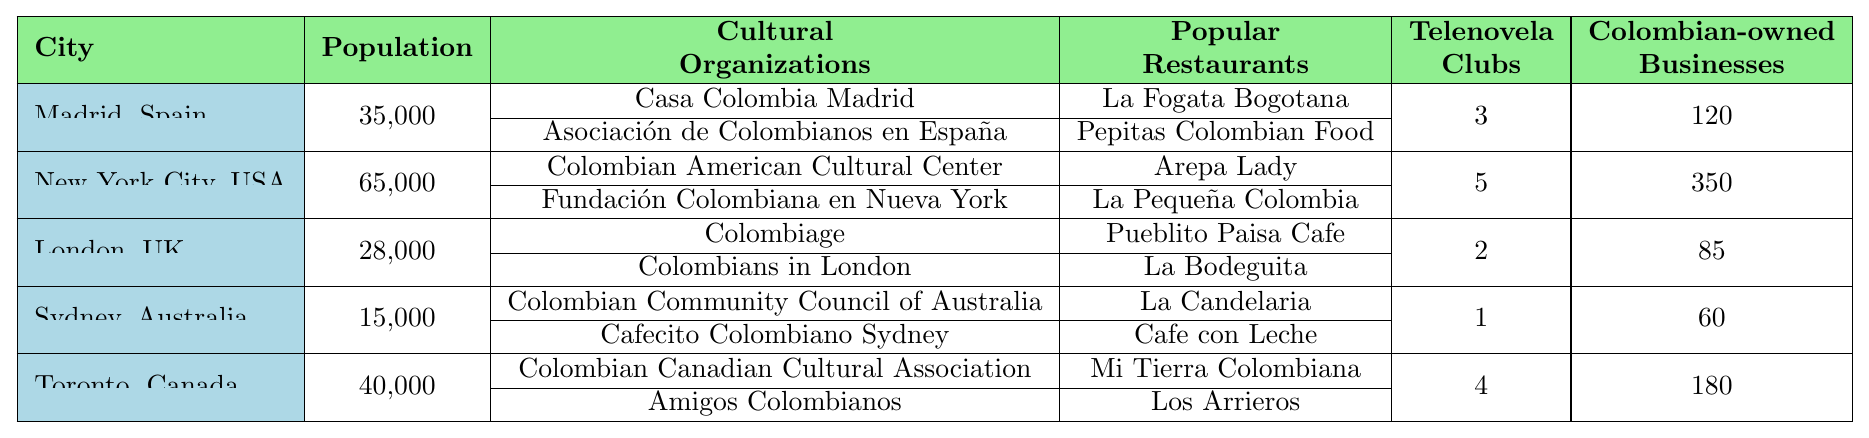What is the Colombian population in New York City? The table shows New York City has a Colombian population of 65,000.
Answer: 65,000 How many annual events does Casa Colombia Madrid organize? The table states that Casa Colombia Madrid organizes 15 annual events.
Answer: 15 Which city has the highest number of Colombian-owned businesses? By comparing the values, New York City has 350 Colombian-owned businesses, which is the highest among the listed cities.
Answer: New York City What is the total number of Colombian-owned businesses in Madrid and London combined? Madrid has 120 Colombian-owned businesses and London has 85. Adding these gives 120 + 85 = 205.
Answer: 205 Does Sydney have more Cultural Organizations than London? Sydney has 2 cultural organizations, while London also has 2. Since they are equal, the answer is no.
Answer: No Which city has the most Telenovela Viewing Clubs? New York City has 5 Telenovela Viewing Clubs, which is the most compared to other cities listed in the table.
Answer: New York City What is the average number of annual events for Colombian cultural organizations across all cities? Calculating the annual events: 15 (Madrid) + 8 (Madrid) + 20 (New York) + 12 (New York) + 10 (London) + 6 (London) + 8 (Sydney) + 5 (Sydney) + 14 (Toronto) + 9 (Toronto). The total is 15 + 8 + 20 + 12 + 10 + 6 + 8 + 5 + 14 + 9 = 117. There are 10 cultural organizations, so 117 / 10 = 11.7 annual events on average.
Answer: 11.7 Which city has the fewest Telenovela Viewing Clubs? The table indicates that Sydney has the least, with only 1 Telenovela Viewing Club.
Answer: Sydney Are there more annual events organized in Toronto than in Sydney? Toronto has 23 annual events (14 + 9) and Sydney has 13 (8 + 5). Since 23 is greater than 13, the answer is yes.
Answer: Yes What city has the lowest Colombian population, and what is that population? The lowest Colombian population in the table is Sydney with 15,000 people.
Answer: Sydney, 15,000 If you combine the number of Cultural Organizations from Madrid and New York City, how many organizations are there in total? Madrid has 2 organizations and New York City also has 2. Adding them gives 2 + 2 = 4.
Answer: 4 